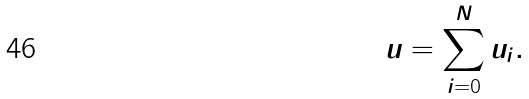Convert formula to latex. <formula><loc_0><loc_0><loc_500><loc_500>u = \sum _ { i = 0 } ^ { N } u _ { i } .</formula> 